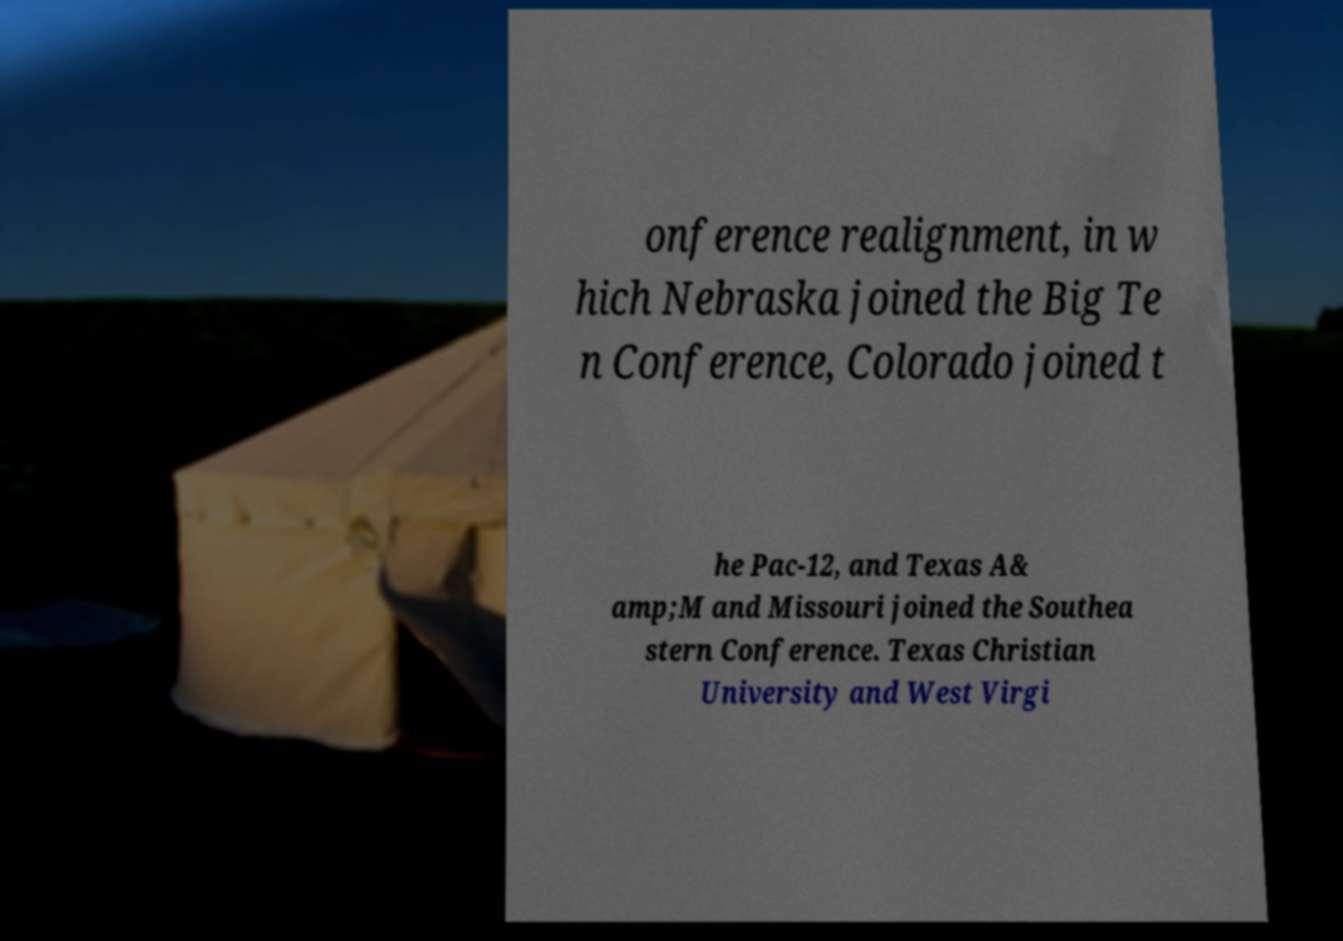Please read and relay the text visible in this image. What does it say? onference realignment, in w hich Nebraska joined the Big Te n Conference, Colorado joined t he Pac-12, and Texas A& amp;M and Missouri joined the Southea stern Conference. Texas Christian University and West Virgi 